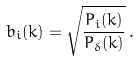<formula> <loc_0><loc_0><loc_500><loc_500>b _ { i } ( k ) = \sqrt { \frac { P _ { i } ( k ) } { P _ { \delta } ( k ) } } \, .</formula> 